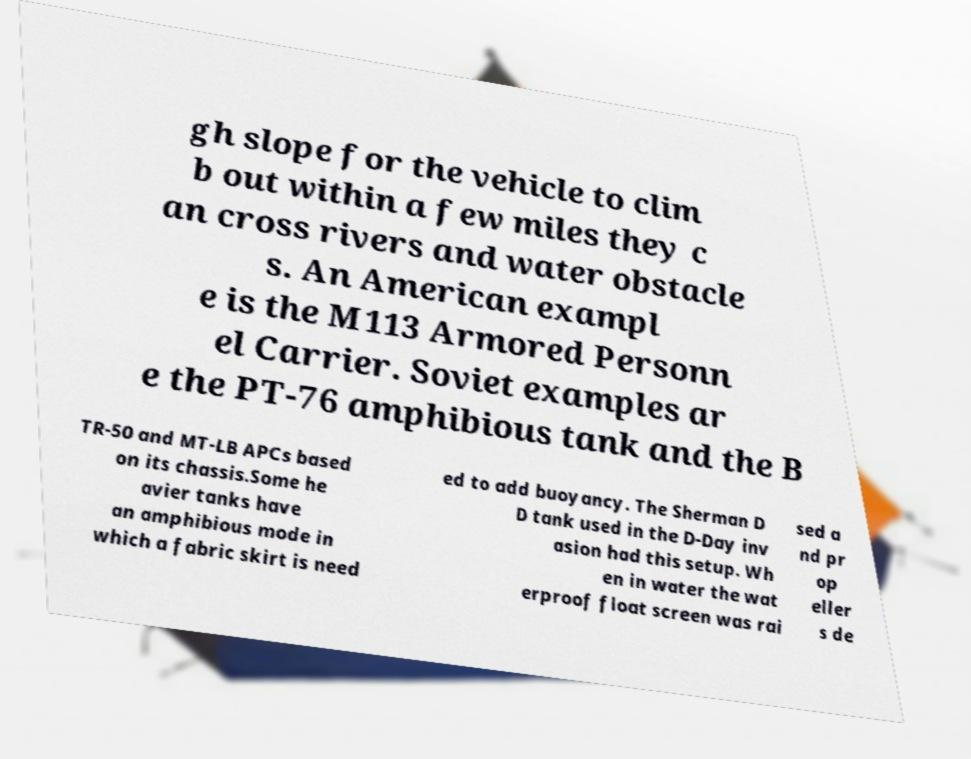There's text embedded in this image that I need extracted. Can you transcribe it verbatim? gh slope for the vehicle to clim b out within a few miles they c an cross rivers and water obstacle s. An American exampl e is the M113 Armored Personn el Carrier. Soviet examples ar e the PT-76 amphibious tank and the B TR-50 and MT-LB APCs based on its chassis.Some he avier tanks have an amphibious mode in which a fabric skirt is need ed to add buoyancy. The Sherman D D tank used in the D-Day inv asion had this setup. Wh en in water the wat erproof float screen was rai sed a nd pr op eller s de 